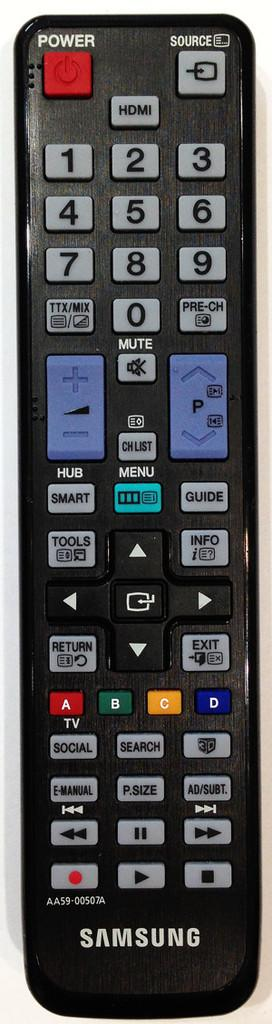<image>
Describe the image concisely. A Samsung TV remote showcasing all of the buttons available. 